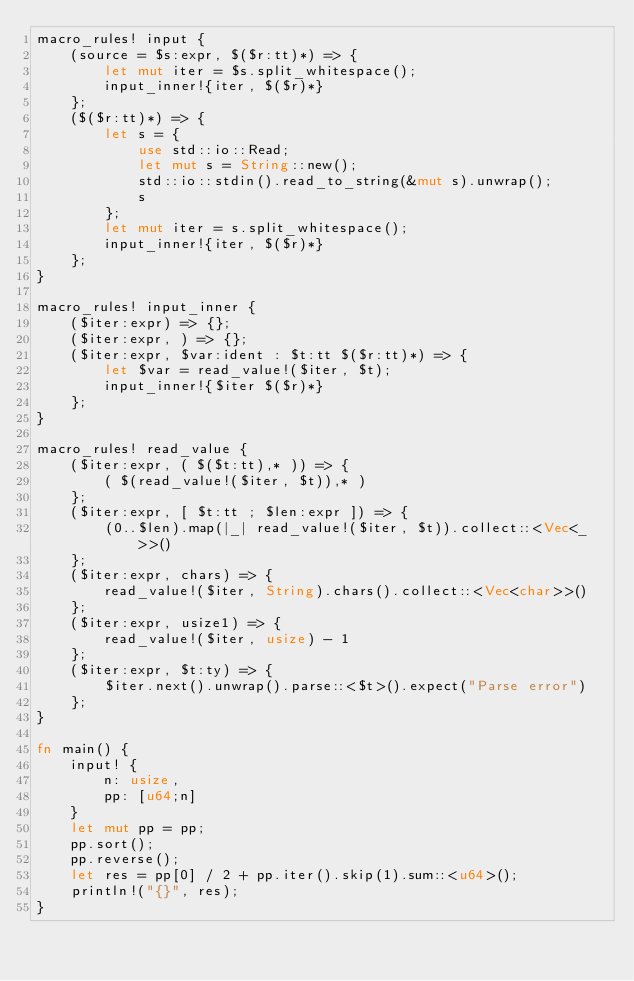Convert code to text. <code><loc_0><loc_0><loc_500><loc_500><_Rust_>macro_rules! input {
    (source = $s:expr, $($r:tt)*) => {
        let mut iter = $s.split_whitespace();
        input_inner!{iter, $($r)*}
    };
    ($($r:tt)*) => {
        let s = {
            use std::io::Read;
            let mut s = String::new();
            std::io::stdin().read_to_string(&mut s).unwrap();
            s
        };
        let mut iter = s.split_whitespace();
        input_inner!{iter, $($r)*}
    };
}

macro_rules! input_inner {
    ($iter:expr) => {};
    ($iter:expr, ) => {};
    ($iter:expr, $var:ident : $t:tt $($r:tt)*) => {
        let $var = read_value!($iter, $t);
        input_inner!{$iter $($r)*}
    };
}

macro_rules! read_value {
    ($iter:expr, ( $($t:tt),* )) => {
        ( $(read_value!($iter, $t)),* )
    };
    ($iter:expr, [ $t:tt ; $len:expr ]) => {
        (0..$len).map(|_| read_value!($iter, $t)).collect::<Vec<_>>()
    };
    ($iter:expr, chars) => {
        read_value!($iter, String).chars().collect::<Vec<char>>()
    };
    ($iter:expr, usize1) => {
        read_value!($iter, usize) - 1
    };
    ($iter:expr, $t:ty) => {
        $iter.next().unwrap().parse::<$t>().expect("Parse error")
    };
}

fn main() {
    input! {
        n: usize,
        pp: [u64;n]
    }
    let mut pp = pp;
    pp.sort();
    pp.reverse();
    let res = pp[0] / 2 + pp.iter().skip(1).sum::<u64>();
    println!("{}", res);
}
</code> 